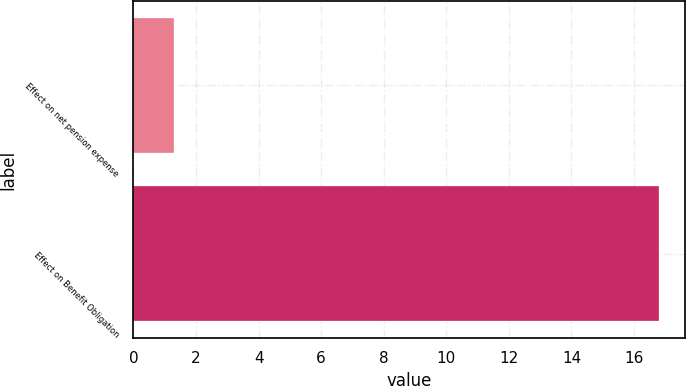Convert chart to OTSL. <chart><loc_0><loc_0><loc_500><loc_500><bar_chart><fcel>Effect on net pension expense<fcel>Effect on Benefit Obligation<nl><fcel>1.3<fcel>16.8<nl></chart> 